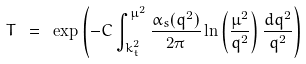Convert formula to latex. <formula><loc_0><loc_0><loc_500><loc_500>T \ = \ \exp \left ( - C \int _ { k _ { t } ^ { 2 } } ^ { \mu ^ { 2 } } \frac { \alpha _ { s } ( q ^ { 2 } ) } { 2 \pi } \ln \left ( \frac { \mu ^ { 2 } } { q ^ { 2 } } \right ) \frac { d q ^ { 2 } } { q ^ { 2 } } \right )</formula> 